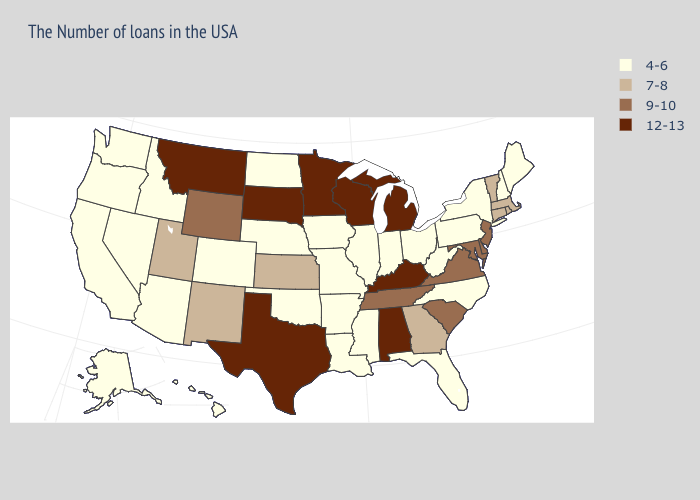Does Kentucky have the highest value in the USA?
Write a very short answer. Yes. Name the states that have a value in the range 4-6?
Be succinct. Maine, New Hampshire, New York, Pennsylvania, North Carolina, West Virginia, Ohio, Florida, Indiana, Illinois, Mississippi, Louisiana, Missouri, Arkansas, Iowa, Nebraska, Oklahoma, North Dakota, Colorado, Arizona, Idaho, Nevada, California, Washington, Oregon, Alaska, Hawaii. What is the highest value in states that border Montana?
Write a very short answer. 12-13. Among the states that border Ohio , which have the lowest value?
Concise answer only. Pennsylvania, West Virginia, Indiana. What is the value of Virginia?
Short answer required. 9-10. What is the lowest value in states that border Michigan?
Be succinct. 4-6. Does Pennsylvania have the same value as Hawaii?
Keep it brief. Yes. What is the value of New Mexico?
Give a very brief answer. 7-8. Name the states that have a value in the range 4-6?
Keep it brief. Maine, New Hampshire, New York, Pennsylvania, North Carolina, West Virginia, Ohio, Florida, Indiana, Illinois, Mississippi, Louisiana, Missouri, Arkansas, Iowa, Nebraska, Oklahoma, North Dakota, Colorado, Arizona, Idaho, Nevada, California, Washington, Oregon, Alaska, Hawaii. Which states hav the highest value in the Northeast?
Concise answer only. New Jersey. Does Oregon have the same value as Colorado?
Be succinct. Yes. What is the highest value in the MidWest ?
Concise answer only. 12-13. Name the states that have a value in the range 4-6?
Concise answer only. Maine, New Hampshire, New York, Pennsylvania, North Carolina, West Virginia, Ohio, Florida, Indiana, Illinois, Mississippi, Louisiana, Missouri, Arkansas, Iowa, Nebraska, Oklahoma, North Dakota, Colorado, Arizona, Idaho, Nevada, California, Washington, Oregon, Alaska, Hawaii. Does Oklahoma have the highest value in the South?
Keep it brief. No. Which states hav the highest value in the South?
Be succinct. Kentucky, Alabama, Texas. 